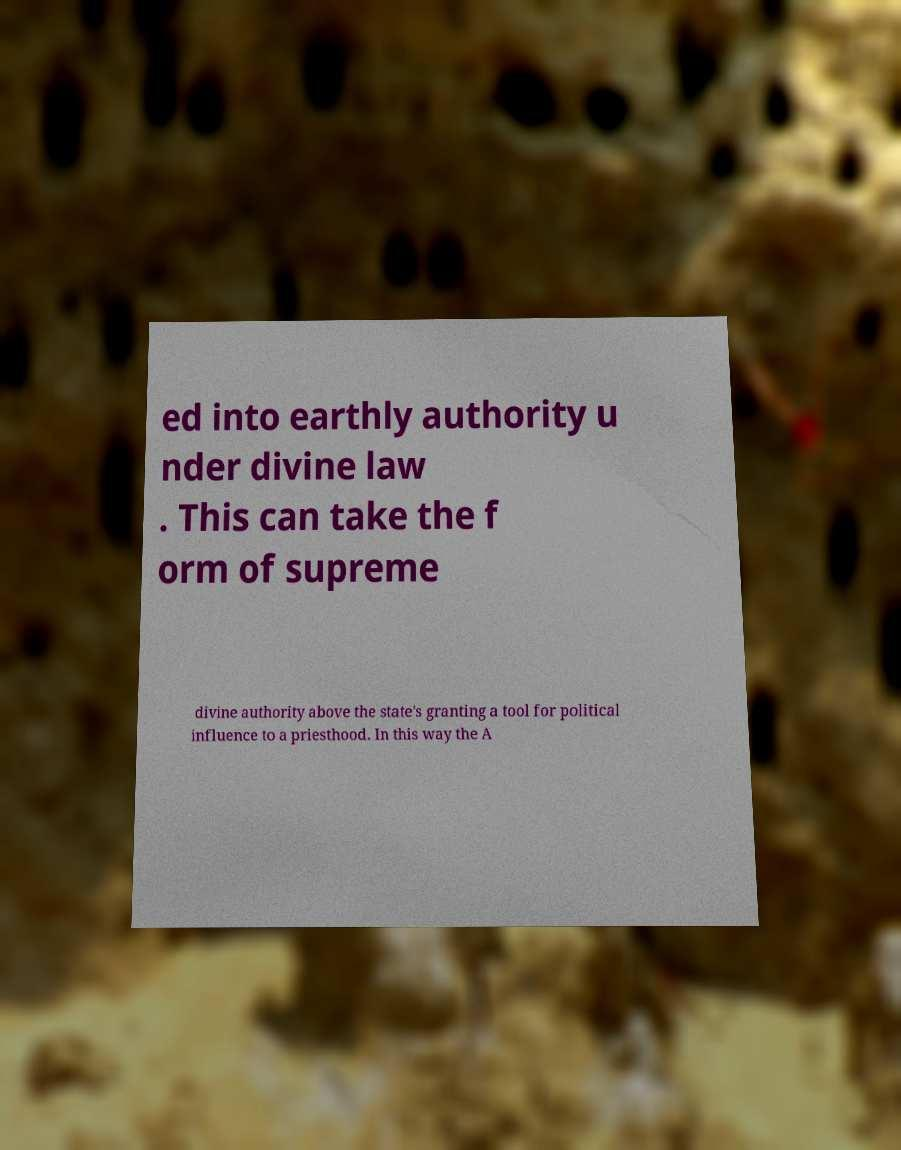Please read and relay the text visible in this image. What does it say? ed into earthly authority u nder divine law . This can take the f orm of supreme divine authority above the state's granting a tool for political influence to a priesthood. In this way the A 